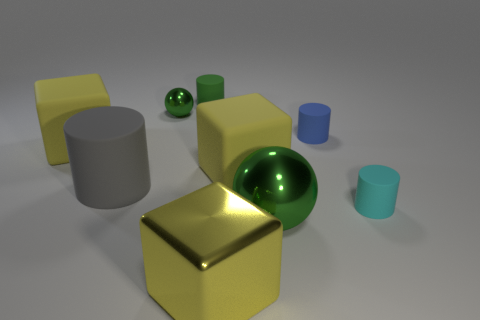What is the size of the other metal sphere that is the same color as the big ball?
Provide a short and direct response. Small. What number of small objects are both on the right side of the large ball and on the left side of the tiny blue cylinder?
Offer a terse response. 0. Is the material of the cyan thing the same as the blue object?
Your answer should be very brief. Yes. The big yellow rubber thing that is on the right side of the yellow object in front of the tiny cylinder right of the blue cylinder is what shape?
Ensure brevity in your answer.  Cube. There is a big thing that is behind the big gray rubber thing and to the right of the gray rubber object; what is its material?
Offer a very short reply. Rubber. There is a tiny rubber cylinder left of the metallic sphere that is right of the small cylinder behind the blue matte cylinder; what color is it?
Give a very brief answer. Green. What number of red things are big cubes or large objects?
Provide a short and direct response. 0. How many other things are the same size as the cyan rubber object?
Offer a very short reply. 3. What number of brown blocks are there?
Your answer should be compact. 0. Is the green ball that is behind the blue matte object made of the same material as the block right of the yellow metal object?
Your response must be concise. No. 